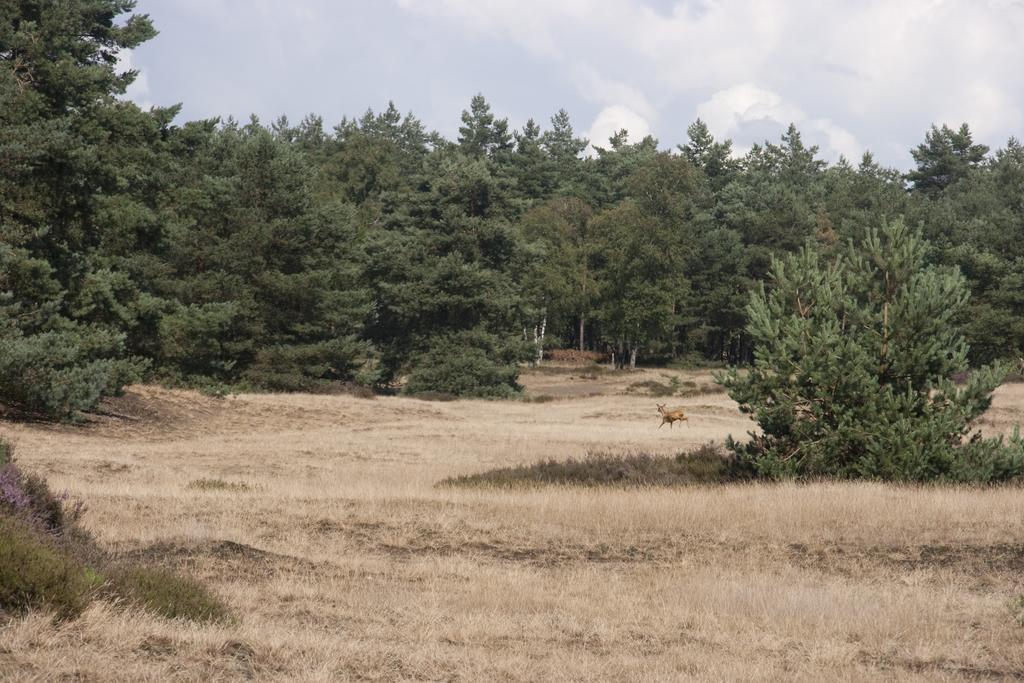What is on the ground in the image? There is an animal on the ground in the image. What can be seen in the distance behind the animal? There are trees in the background of the image. What else is visible in the background of the image? The sky is visible in the background of the image. What type of fuel is the animal using to move in the image? The animal does not use fuel to move in the image; it is a living creature and moves naturally. 